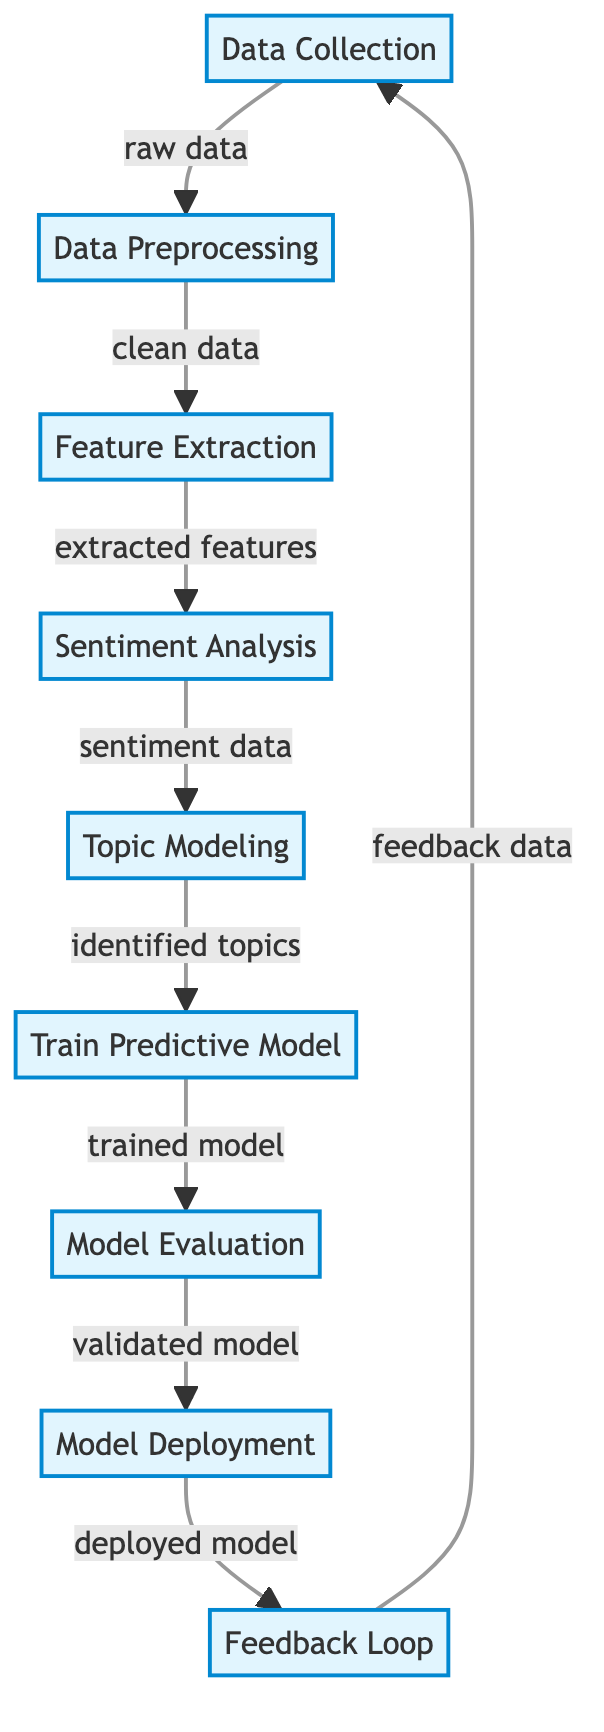What is the first process in the diagram? The diagram starts with "Data Collection" which is labeled as the first process before any other nodes.
Answer: Data Collection How many processes are in the diagram? There are nine distinct processes listed in the diagram from Data Collection to Feedback Loop.
Answer: Nine What type of data is produced after Feature Extraction? The output of Feature Extraction is labeled "extracted features", which is the type of data passed onto the next process.
Answer: Extracted features Which process comes before Model Deployment? The diagram indicates that "Model Evaluation" is the process that directly precedes "Model Deployment".
Answer: Model Evaluation What feedback mechanism is shown in the final step of the diagram? The diagram shows a "Feedback Loop" that connects back to "Data Collection", indicating a cyclical process of improvement.
Answer: Feedback Loop What is the final output of the diagram's processing sequence? The final process in the diagram illustrates "deployed model", representing the ultimate output after all previous steps have been completed.
Answer: Deployed model What type of analysis is performed after Feature Extraction? According to the diagram, "Sentiment Analysis" is conducted immediately following Feature Extraction to analyze the extracted features.
Answer: Sentiment Analysis How does the feedback influence the initial process in the diagram? The "Feedback Loop" connects the output back to "Data Collection", indicating that feedback data informs and improves the initial data collection process.
Answer: Feedback Which process follows Topic Modeling? The next step after "Topic Modeling" in the diagram is "Train Predictive Model", which indicates the progression of tasks following topic identification.
Answer: Train Predictive Model 